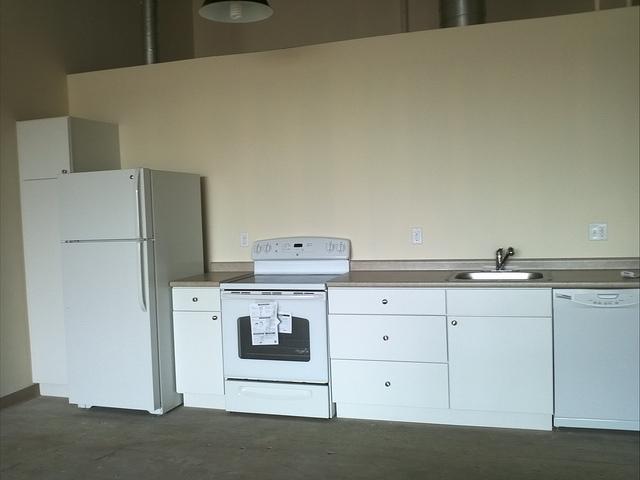How many drawers are next to the fridge?
Give a very brief answer. 1. 